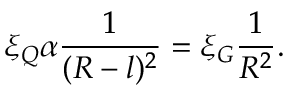<formula> <loc_0><loc_0><loc_500><loc_500>\xi _ { Q } \alpha \frac { 1 } { ( R - l ) ^ { 2 } } = \xi _ { G } \frac { 1 } { R ^ { 2 } } .</formula> 